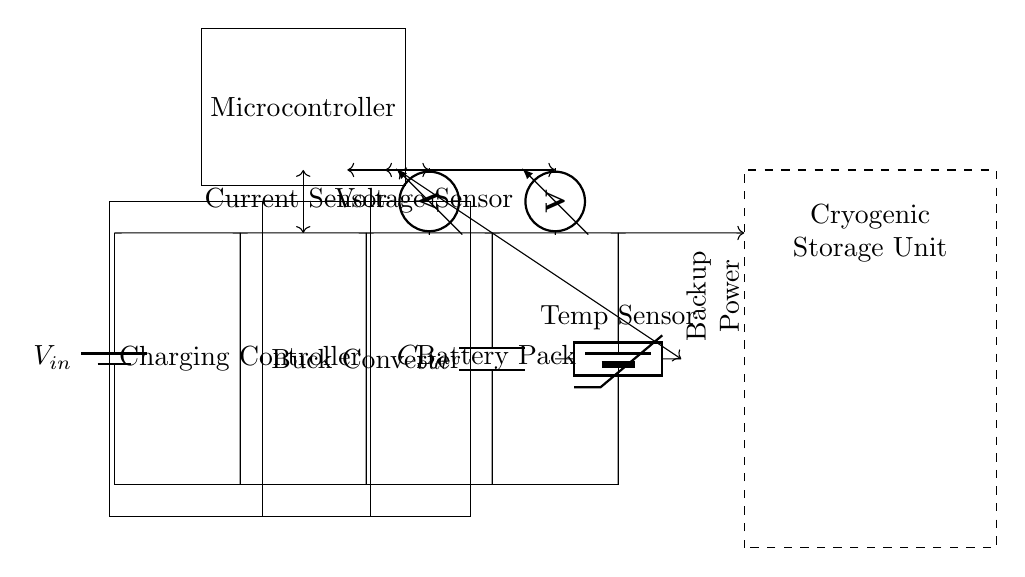What is the input component in the circuit? The input component is a battery, labeled as V_in, which serves as the power source for the circuit.
Answer: battery What is the role of the Buck Converter? The Buck Converter is used to step down the voltage from the charging controller to a lower level suitable for charging the battery pack.
Answer: step down voltage What does the temperature sensor do? The temperature sensor measures the temperature within the circuit, ensuring optimal conditions for charging and operating the cryogenic storage unit.
Answer: measures temperature How many main components are used in this charging circuit? The main components consist of the power source, charging controller, buck converter, output capacitor, battery pack, temperature sensor, and the microcontroller, totaling seven components.
Answer: seven What is the purpose of the current sensor? The current sensor monitors the amount of current flowing through the circuit to ensure that it stays within safe operational limits while charging the backup batteries.
Answer: monitor current What happens if the temperature exceeds normal levels? If the temperature exceeds normal levels, the microcontroller can initiate safety protocols to stop charging or adjust the operation of the Buck Converter to prevent damage.
Answer: initiate safety protocols What is the output component labeled as? The output component is labeled as the Battery Pack, which receives the charged energy from the circuit.
Answer: Battery Pack 